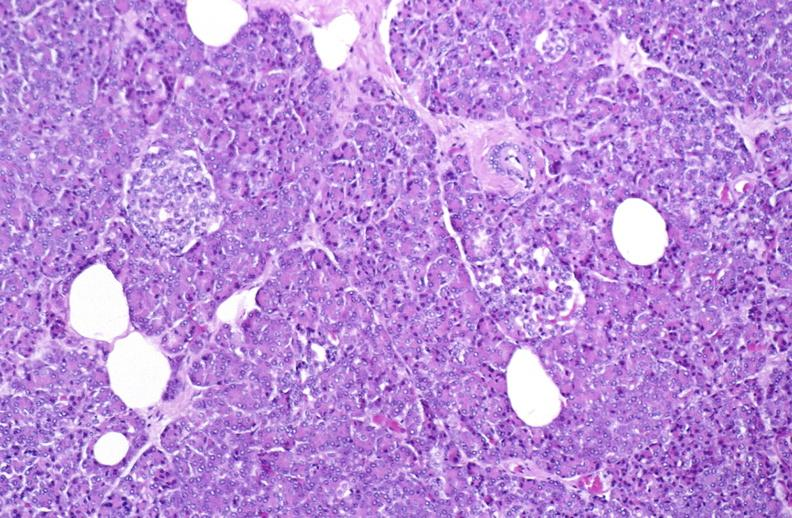where is this?
Answer the question using a single word or phrase. Pancreas 